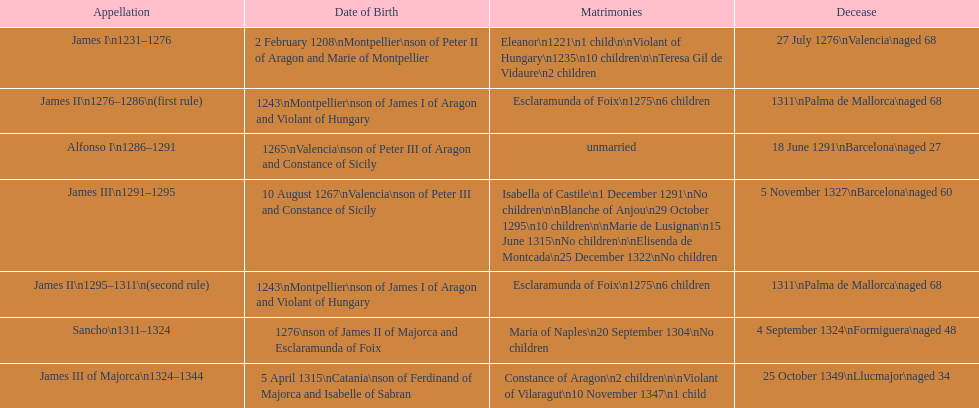How many of these monarchs died before the age of 65? 4. 